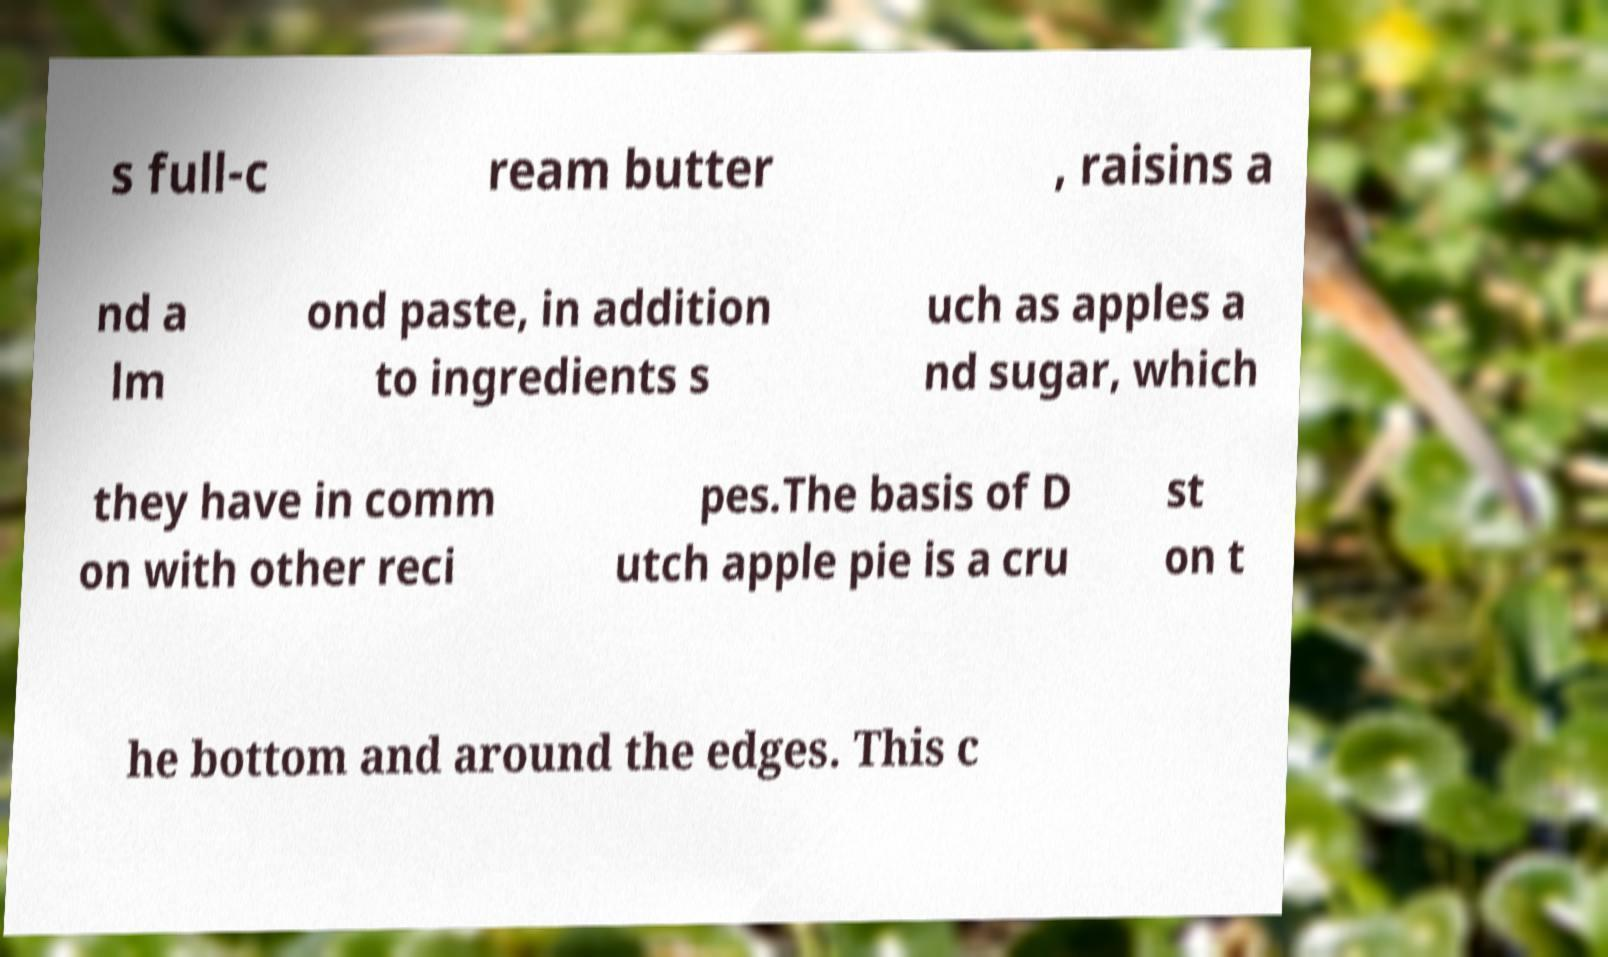Can you read and provide the text displayed in the image?This photo seems to have some interesting text. Can you extract and type it out for me? s full-c ream butter , raisins a nd a lm ond paste, in addition to ingredients s uch as apples a nd sugar, which they have in comm on with other reci pes.The basis of D utch apple pie is a cru st on t he bottom and around the edges. This c 